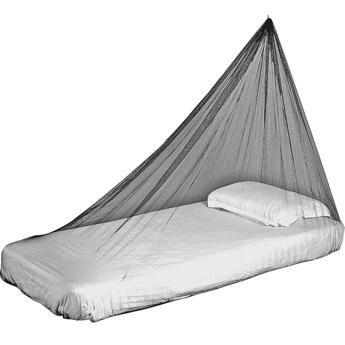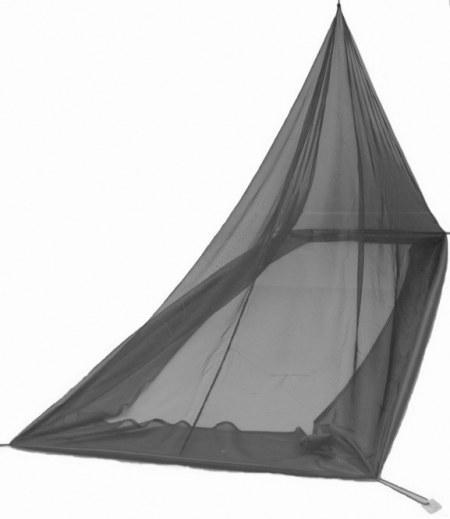The first image is the image on the left, the second image is the image on the right. For the images displayed, is the sentence "Exactly one net is white." factually correct? Answer yes or no. No. The first image is the image on the left, the second image is the image on the right. Analyze the images presented: Is the assertion "In the left image, all pillows are white." valid? Answer yes or no. Yes. 